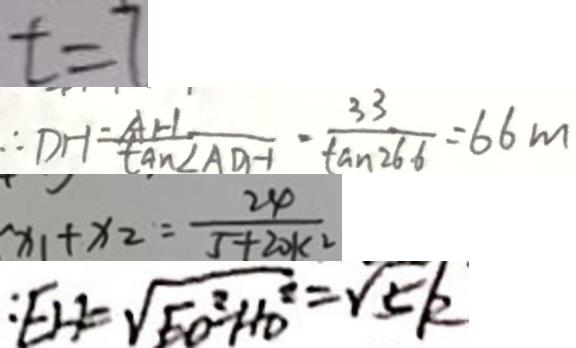<formula> <loc_0><loc_0><loc_500><loc_500>t = 7 
 \therefore D H = \frac { A H } { \tan \angle A D H } \cdot \frac { 3 3 } { \tan 2 6 6 } = 6 6 m 
 x _ { 1 } + x _ { 2 } = \frac { 2 4 } { 5 + 2 0 k ^ { 2 } } 
 : E H = \sqrt { E O ^ { 2 } - H D ^ { 2 } } = \sqrt { 5 } k</formula> 